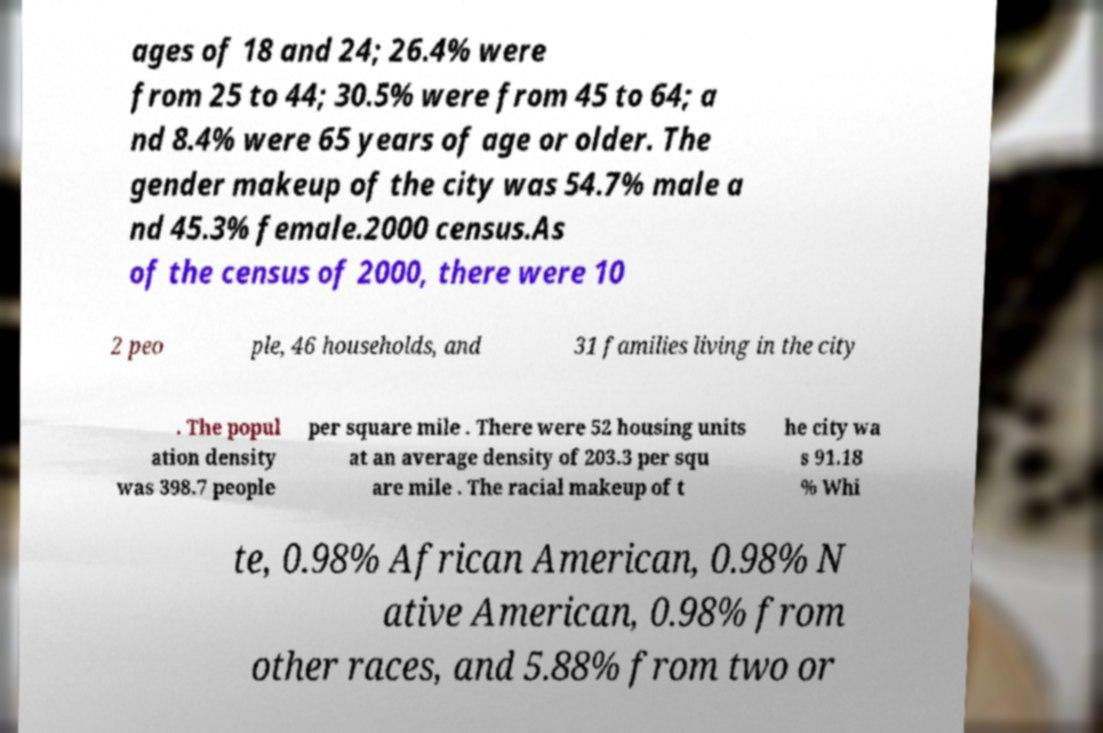Can you read and provide the text displayed in the image?This photo seems to have some interesting text. Can you extract and type it out for me? ages of 18 and 24; 26.4% were from 25 to 44; 30.5% were from 45 to 64; a nd 8.4% were 65 years of age or older. The gender makeup of the city was 54.7% male a nd 45.3% female.2000 census.As of the census of 2000, there were 10 2 peo ple, 46 households, and 31 families living in the city . The popul ation density was 398.7 people per square mile . There were 52 housing units at an average density of 203.3 per squ are mile . The racial makeup of t he city wa s 91.18 % Whi te, 0.98% African American, 0.98% N ative American, 0.98% from other races, and 5.88% from two or 